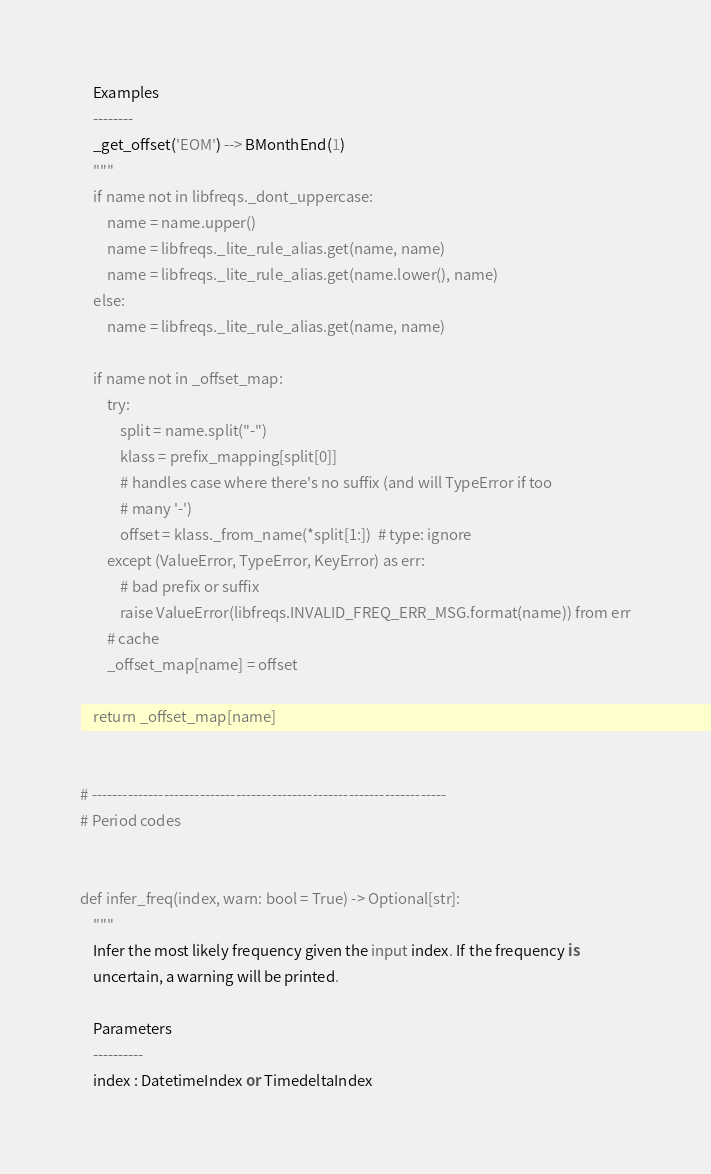<code> <loc_0><loc_0><loc_500><loc_500><_Python_>
    Examples
    --------
    _get_offset('EOM') --> BMonthEnd(1)
    """
    if name not in libfreqs._dont_uppercase:
        name = name.upper()
        name = libfreqs._lite_rule_alias.get(name, name)
        name = libfreqs._lite_rule_alias.get(name.lower(), name)
    else:
        name = libfreqs._lite_rule_alias.get(name, name)

    if name not in _offset_map:
        try:
            split = name.split("-")
            klass = prefix_mapping[split[0]]
            # handles case where there's no suffix (and will TypeError if too
            # many '-')
            offset = klass._from_name(*split[1:])  # type: ignore
        except (ValueError, TypeError, KeyError) as err:
            # bad prefix or suffix
            raise ValueError(libfreqs.INVALID_FREQ_ERR_MSG.format(name)) from err
        # cache
        _offset_map[name] = offset

    return _offset_map[name]


# ---------------------------------------------------------------------
# Period codes


def infer_freq(index, warn: bool = True) -> Optional[str]:
    """
    Infer the most likely frequency given the input index. If the frequency is
    uncertain, a warning will be printed.

    Parameters
    ----------
    index : DatetimeIndex or TimedeltaIndex</code> 